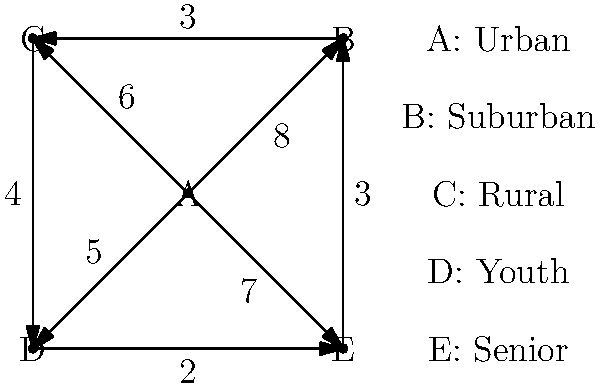In a political campaign, the weighted graph represents the optimal distribution of resources across different demographics. Vertices represent demographic groups, and edge weights indicate the impact of resource allocation between connected groups. Given a budget of 20 units, what is the maximum total impact achievable by allocating resources to exactly three demographic groups? To solve this problem, we need to follow these steps:

1. Identify all possible combinations of three demographic groups (vertices).
2. For each combination, calculate the total impact by summing the edge weights between the chosen vertices.
3. Find the combination with the maximum total impact.

Possible combinations of three vertices:
1. A, B, C
2. A, B, D
3. A, B, E
4. A, C, D
5. A, C, E
6. A, D, E
7. B, C, D
8. B, C, E
9. B, D, E
10. C, D, E

Calculating the impact for each combination:
1. A, B, C: $8 + 6 + 3 = 17$
2. A, B, D: $8 + 5 = 13$
3. A, B, E: $8 + 7 = 15$
4. A, C, D: $6 + 5 + 4 = 15$
5. A, C, E: $6 + 7 = 13$
6. A, D, E: $5 + 7 = 12$
7. B, C, D: $3 + 4 = 7$
8. B, C, E: $3 + 3 = 6$
9. B, D, E: $3 + 2 = 5$
10. C, D, E: $4 + 2 = 6$

The maximum total impact is achieved by selecting vertices A, B, and C, resulting in a total impact of 17.
Answer: 17 